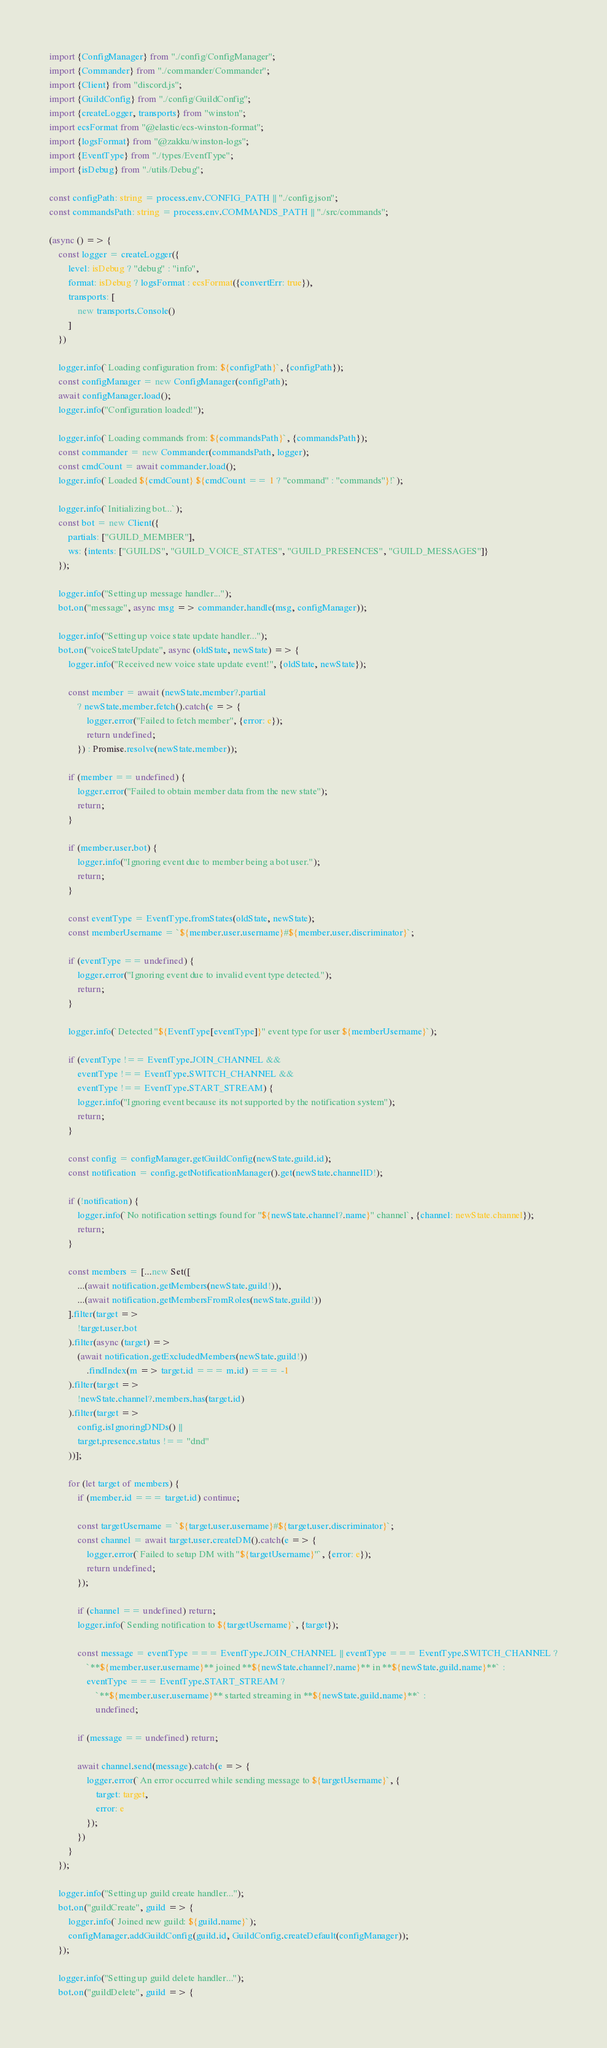Convert code to text. <code><loc_0><loc_0><loc_500><loc_500><_TypeScript_>import {ConfigManager} from "./config/ConfigManager";
import {Commander} from "./commander/Commander";
import {Client} from "discord.js";
import {GuildConfig} from "./config/GuildConfig";
import {createLogger, transports} from "winston";
import ecsFormat from "@elastic/ecs-winston-format";
import {logsFormat} from "@zakku/winston-logs";
import {EventType} from "./types/EventType";
import {isDebug} from "./utils/Debug";

const configPath: string = process.env.CONFIG_PATH || "./config.json";
const commandsPath: string = process.env.COMMANDS_PATH || "./src/commands";

(async () => {
    const logger = createLogger({
        level: isDebug ? "debug" : "info",
        format: isDebug ? logsFormat : ecsFormat({convertErr: true}),
        transports: [
            new transports.Console()
        ]
    })

    logger.info(`Loading configuration from: ${configPath}`, {configPath});
    const configManager = new ConfigManager(configPath);
    await configManager.load();
    logger.info("Configuration loaded!");

    logger.info(`Loading commands from: ${commandsPath}`, {commandsPath});
    const commander = new Commander(commandsPath, logger);
    const cmdCount = await commander.load();
    logger.info(`Loaded ${cmdCount} ${cmdCount == 1 ? "command" : "commands"}!`);

    logger.info(`Initializing bot...`);
    const bot = new Client({
        partials: ["GUILD_MEMBER"],
        ws: {intents: ["GUILDS", "GUILD_VOICE_STATES", "GUILD_PRESENCES", "GUILD_MESSAGES"]}
    });

    logger.info("Setting up message handler...");
    bot.on("message", async msg => commander.handle(msg, configManager));

    logger.info("Setting up voice state update handler...");
    bot.on("voiceStateUpdate", async (oldState, newState) => {
        logger.info("Received new voice state update event!", {oldState, newState});

        const member = await (newState.member?.partial
            ? newState.member.fetch().catch(e => {
                logger.error("Failed to fetch member", {error: e});
                return undefined;
            }) : Promise.resolve(newState.member));

        if (member == undefined) {
            logger.error("Failed to obtain member data from the new state");
            return;
        }

        if (member.user.bot) {
            logger.info("Ignoring event due to member being a bot user.");
            return;
        }

        const eventType = EventType.fromStates(oldState, newState);
        const memberUsername = `${member.user.username}#${member.user.discriminator}`;

        if (eventType == undefined) {
            logger.error("Ignoring event due to invalid event type detected.");
            return;
        }

        logger.info(`Detected "${EventType[eventType]}" event type for user ${memberUsername}`);

        if (eventType !== EventType.JOIN_CHANNEL &&
            eventType !== EventType.SWITCH_CHANNEL &&
            eventType !== EventType.START_STREAM) {
            logger.info("Ignoring event because its not supported by the notification system");
            return;
        }

        const config = configManager.getGuildConfig(newState.guild.id);
        const notification = config.getNotificationManager().get(newState.channelID!);

        if (!notification) {
            logger.info(`No notification settings found for "${newState.channel?.name}" channel`, {channel: newState.channel});
            return;
        }

        const members = [...new Set([
            ...(await notification.getMembers(newState.guild!)),
            ...(await notification.getMembersFromRoles(newState.guild!))
        ].filter(target =>
            !target.user.bot
        ).filter(async (target) =>
            (await notification.getExcludedMembers(newState.guild!))
                .findIndex(m => target.id === m.id) === -1
        ).filter(target =>
            !newState.channel?.members.has(target.id)
        ).filter(target =>
            config.isIgnoringDNDs() ||
            target.presence.status !== "dnd"
        ))];

        for (let target of members) {
            if (member.id === target.id) continue;

            const targetUsername = `${target.user.username}#${target.user.discriminator}`;
            const channel = await target.user.createDM().catch(e => {
                logger.error(`Failed to setup DM with "${targetUsername}"`, {error: e});
                return undefined;
            });

            if (channel == undefined) return;
            logger.info(`Sending notification to ${targetUsername}`, {target});

            const message = eventType === EventType.JOIN_CHANNEL || eventType === EventType.SWITCH_CHANNEL ?
                `**${member.user.username}** joined **${newState.channel?.name}** in **${newState.guild.name}**` :
                eventType === EventType.START_STREAM ?
                    `**${member.user.username}** started streaming in **${newState.guild.name}**` :
                    undefined;

            if (message == undefined) return;

            await channel.send(message).catch(e => {
                logger.error(`An error occurred while sending message to ${targetUsername}`, {
                    target: target,
                    error: e
                });
            })
        }
    });

    logger.info("Setting up guild create handler...");
    bot.on("guildCreate", guild => {
        logger.info(`Joined new guild: ${guild.name}`);
        configManager.addGuildConfig(guild.id, GuildConfig.createDefault(configManager));
    });

    logger.info("Setting up guild delete handler...");
    bot.on("guildDelete", guild => {</code> 